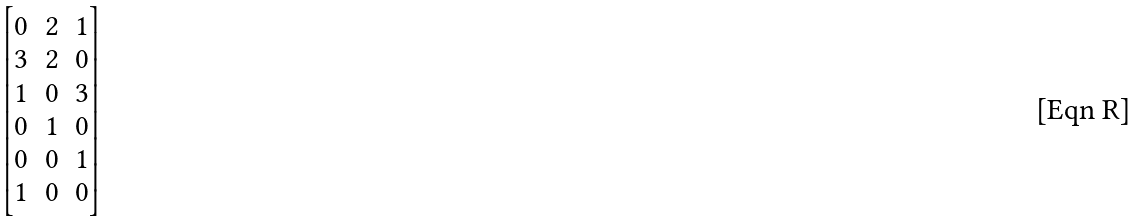Convert formula to latex. <formula><loc_0><loc_0><loc_500><loc_500>\begin{bmatrix} 0 & 2 & 1 \\ 3 & 2 & 0 \\ 1 & 0 & 3 \\ 0 & 1 & 0 \\ 0 & 0 & 1 \\ 1 & 0 & 0 \end{bmatrix}</formula> 